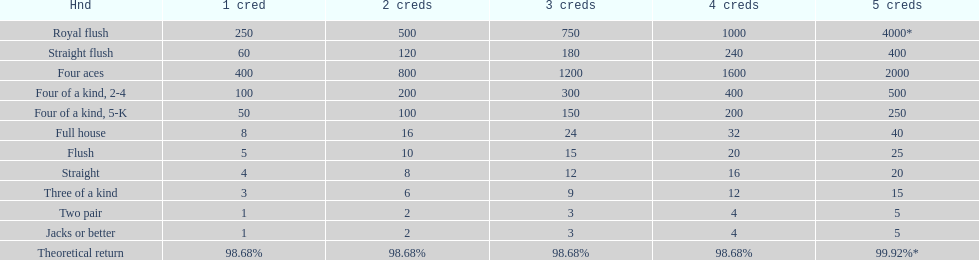The number of credits returned for a one credit bet on a royal flush are. 250. 